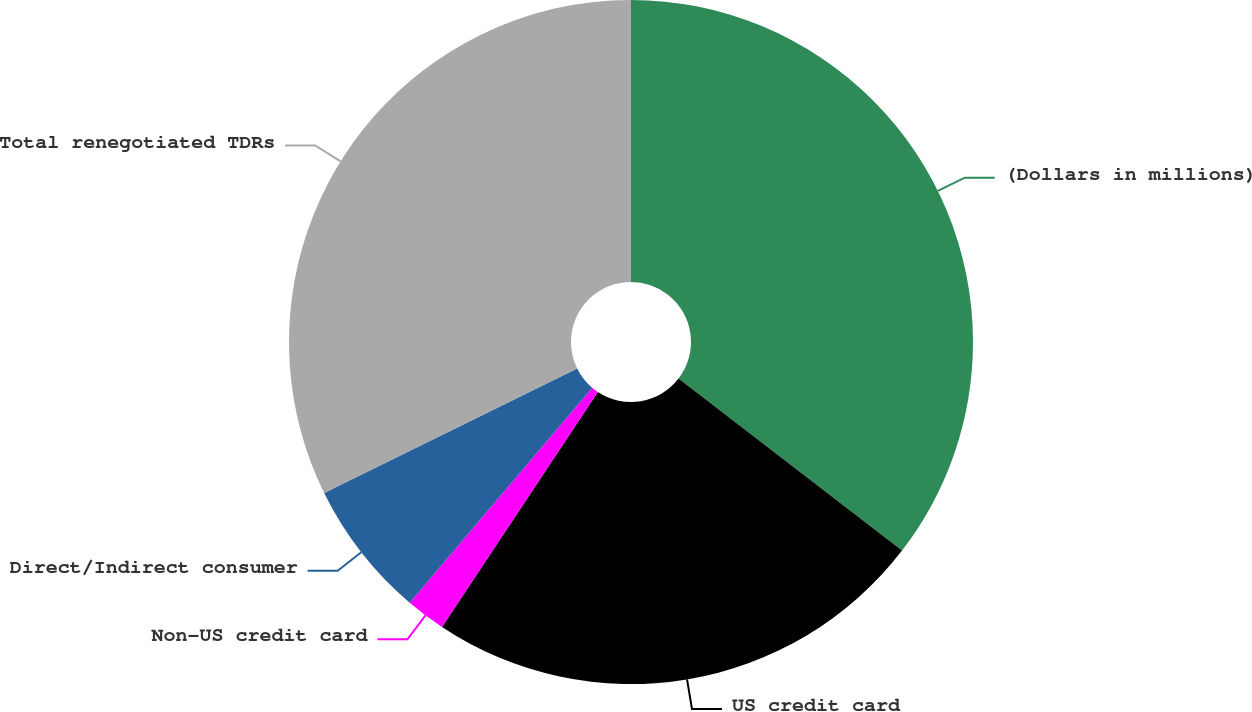<chart> <loc_0><loc_0><loc_500><loc_500><pie_chart><fcel>(Dollars in millions)<fcel>US credit card<fcel>Non-US credit card<fcel>Direct/Indirect consumer<fcel>Total renegotiated TDRs<nl><fcel>35.44%<fcel>23.88%<fcel>1.88%<fcel>6.52%<fcel>32.28%<nl></chart> 